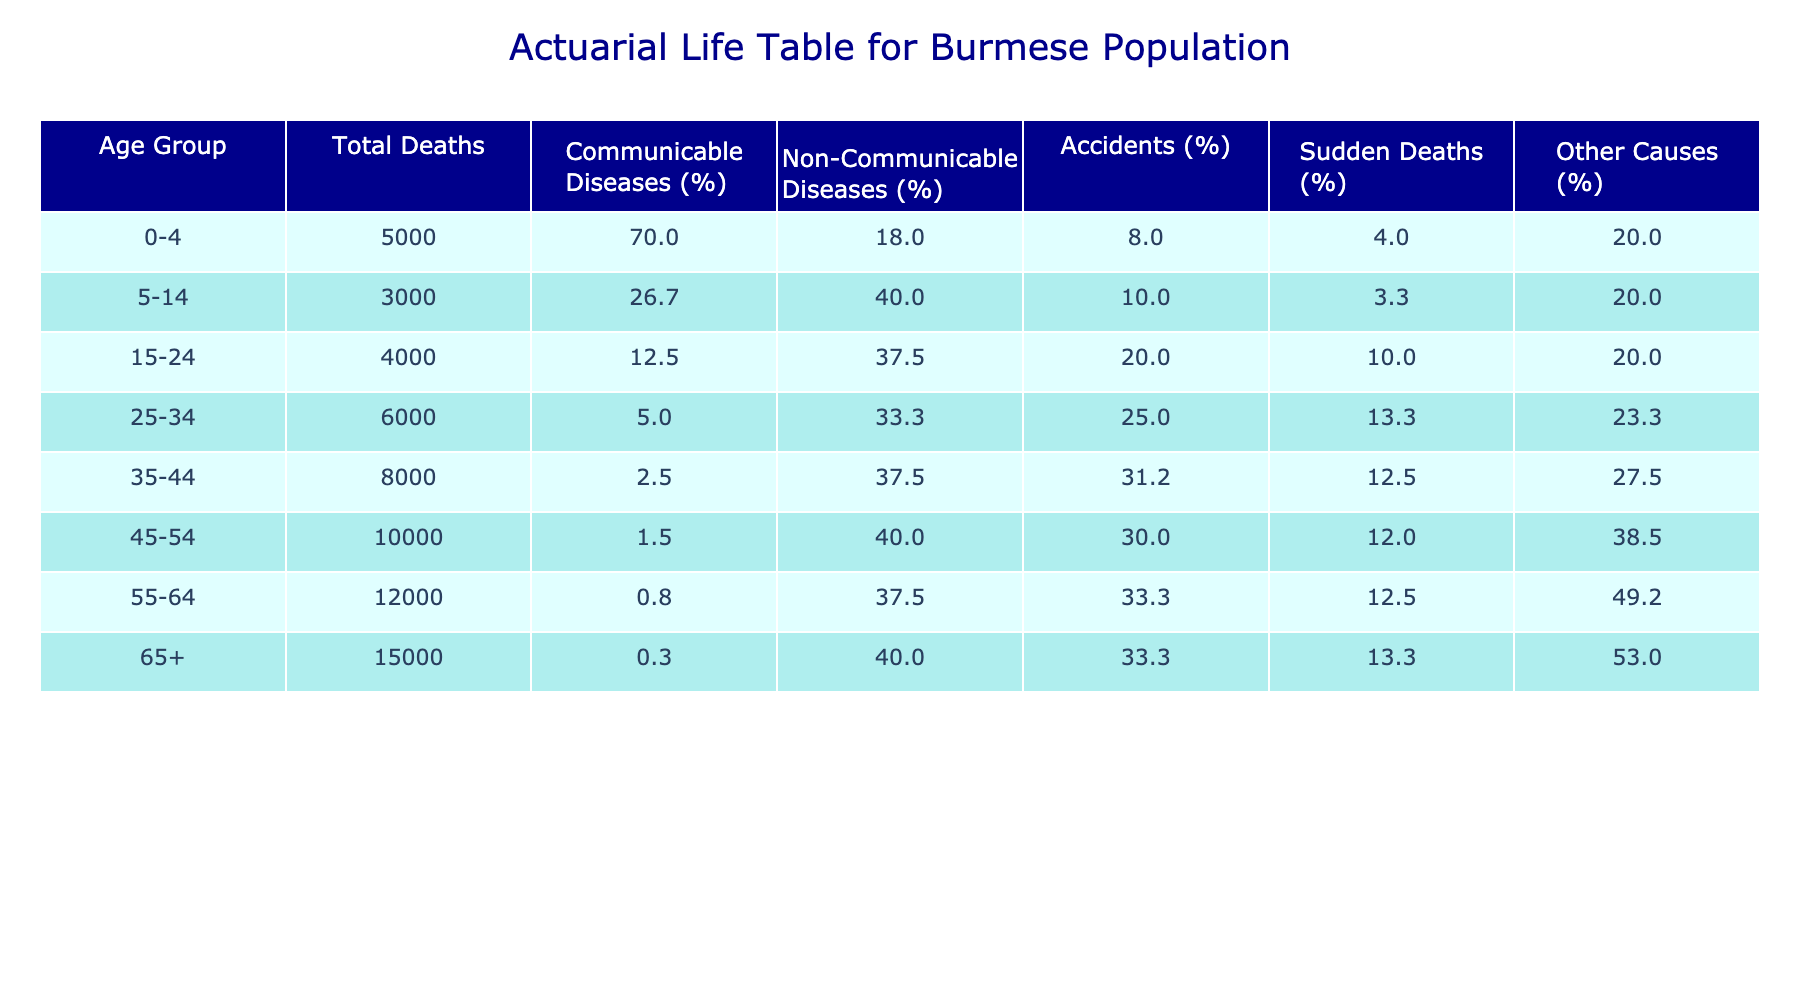What is the total number of deaths in the age group 45-54? The total number of deaths in the age group 45-54 is directly referenced in the table under the 'Total Deaths' column corresponding to this age group. Looking at the table, I see that it lists 10,000 deaths for this age group.
Answer: 10,000 Which age group has the highest percentage of Non-Communicable Diseases? To find the age group with the highest percentage of Non-Communicable Diseases, I can scan the 'Non-Communicable Diseases (%)' column in the table. The highest value in this column appears in the 55-64 age group, which has 37.5%.
Answer: 55-64 How many deaths were caused by accidents in the 35-44 age group? The deaths caused by accidents for the 35-44 age group can be found in the 'Accidents' column of the table for this age range. According to the table, this age group has 2,500 deaths from accidents.
Answer: 2,500 Are there more deaths from Communicable Diseases or Non-Communicable Diseases in the 25-34 age group? To answer this question, I compare the values in the 'Communicable Diseases' and 'Non-Communicable Diseases' columns for the 25-34 age group. The table shows 300 deaths from Communicable Diseases and 2,000 from Non-Communicable Diseases. Since 2,000 is greater than 300, the answer is Non-Communicable Diseases.
Answer: Non-Communicable Diseases What is the total percentage of other causes of death for the age group 65+? To calculate the total percentage of other causes of death for the 65+ age group, I look for the 'Other Causes (%)' in that row. The table indicates it is 53.0%, derived from the column labeled similarly.
Answer: 53.0% What is the difference in total deaths between the age groups 5-14 and 55-64? To find the difference, I first identify the total deaths for each age group. The 5-14 age group has 3,000 total deaths, and the 55-64 age group has 12,000. The difference is calculated as 12,000 - 3,000 = 9,000. Thus, there are 9,000 more deaths in the 55-64 age group compared to the 5-14 age group.
Answer: 9,000 Is it true that the majority of deaths in the 0-4 age group are due to Sudden Deaths? In the 0-4 age group, I look at the 'Sudden Deaths' column which shows 200 deaths compared to the 3,500 deaths from Communicable Diseases. Since 3,500 is larger than 200, it is false that the majority of deaths in this group are due to Sudden Deaths.
Answer: No What percentage of total deaths in the 35-44 age group are attributed to accidents and Sudden Deaths combined? To find this, I first add the number of deaths from accidents (2,500) and Sudden Deaths (1,000) for this age group, yielding 3,500 combined deaths. Then, I calculate the percentage: (3,500 / 8,000) * 100 = 43.75%. Thus, 43.75% of the deaths in this age group are due to accidents and Sudden Deaths combined.
Answer: 43.75% 